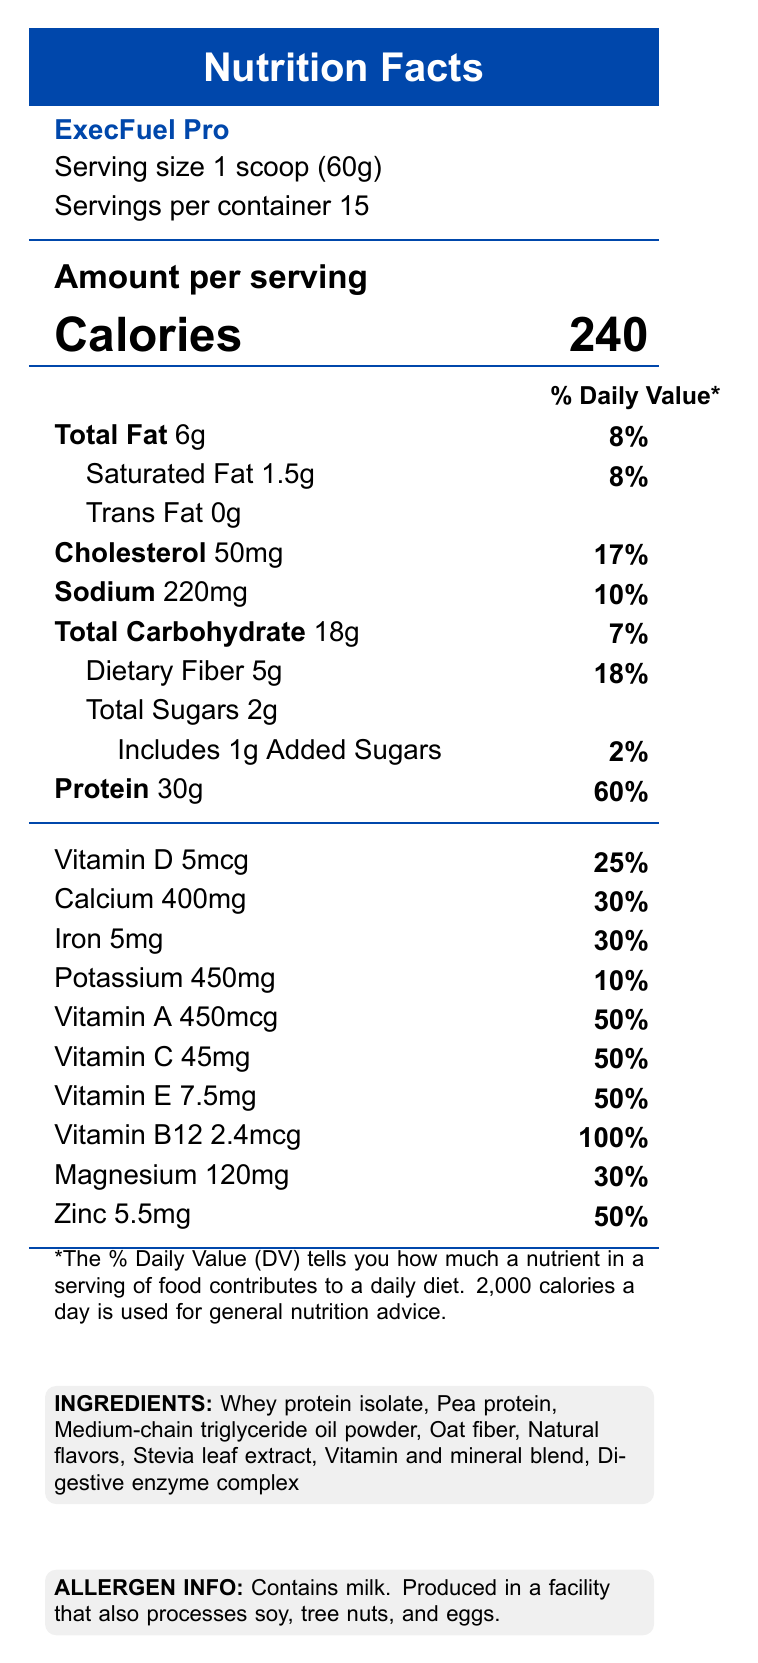what is the serving size for ExecFuel Pro? The serving size is indicated on the label as "1 scoop (60g)".
Answer: 1 scoop (60g) how many servings are in one container of ExecFuel Pro? The nutrition facts label states there are 15 servings per container.
Answer: 15 how many calories are in one serving of ExecFuel Pro? The label shows that each serving of ExecFuel Pro contains 240 calories.
Answer: 240 what percentage of daily value is the protein in ExecFuel Pro? The nutrition facts list the protein content as 30g and 60% of the daily value.
Answer: 60% which ingredient listed is primarily known for its protein content? Among the ingredients, "Whey protein isolate" is known for its high protein content.
Answer: Whey protein isolate what amount of dietary fiber does one serving contain? The nutrition facts state that one serving of ExecFuel Pro contains 5g of dietary fiber.
Answer: 5g how much calcium is provided in each serving? A. 30mg B. 120mg C. 400mg D. 450mg The label shows 400mg of calcium per serving.
Answer: C. 400mg what is the percentage of daily value for Vitamin B12 in one serving of ExecFuel Pro? A. 50% B. 60% C. 80% D. 100% According to the nutrition facts, Vitamin B12 contributes to 100% of the daily value.
Answer: D. 100% does ExecFuel Pro contain any trans fats? The label indicates that the trans fat content is 0g.
Answer: No what is the total carbohydrate content in one serving? The nutrition label states that there are 18 grams of total carbohydrates in one serving.
Answer: 18g how many grams of added sugars are in each serving? The nutrition facts label indicates that there is 1g of added sugars per serving.
Answer: 1g does the product contain any allergens? The label notes that the product contains milk and is produced in a facility that also processes soy, tree nuts, and eggs.
Answer: Yes describe the main idea of this document. The document outlines the nutritional content, serving details, and highlights the benefits of the product such as high protein content, essential vitamins and minerals, and suitability for meal replacement or post-workout nutrition. It also includes ingredient and allergen information.
Answer: The document is a Nutrition Facts Label for a high-protein meal replacement shake called ExecFuel Pro aimed at busy executives, providing detailed nutritional information, ingredients list, allergen information, and marketing claims. how much Vitamin C does one serving of ExecFuel Pro provide? The nutrition facts show that each serving provides 45mg of Vitamin C.
Answer: 45mg is the document rendered using LaTeX? The Nutrition Facts Label does not provide any information about the method used to render the document.
Answer: Cannot be determined what is the projected market growth for the product? The document states that the projected market growth for ExecFuel Pro is 15% CAGR over the next 5 years.
Answer: 15% CAGR over the next 5 years what channels will be used for distribution? A. Direct-to-consumer e-commerce B. High-end fitness centers C. Corporate wellness programs D. Specialty health food stores E. All of the above The distribution channels listed include direct-to-consumer e-commerce, high-end fitness centers, corporate wellness programs, and specialty health food stores.
Answer: E. All of the above what is ExecFuel Pro's competitive advantage over leading brands? The document highlights ExecFuel Pro's higher protein content and more comprehensive vitamin profile as its competitive advantage over leading brands.
Answer: Higher protein content and more comprehensive vitamin profile 